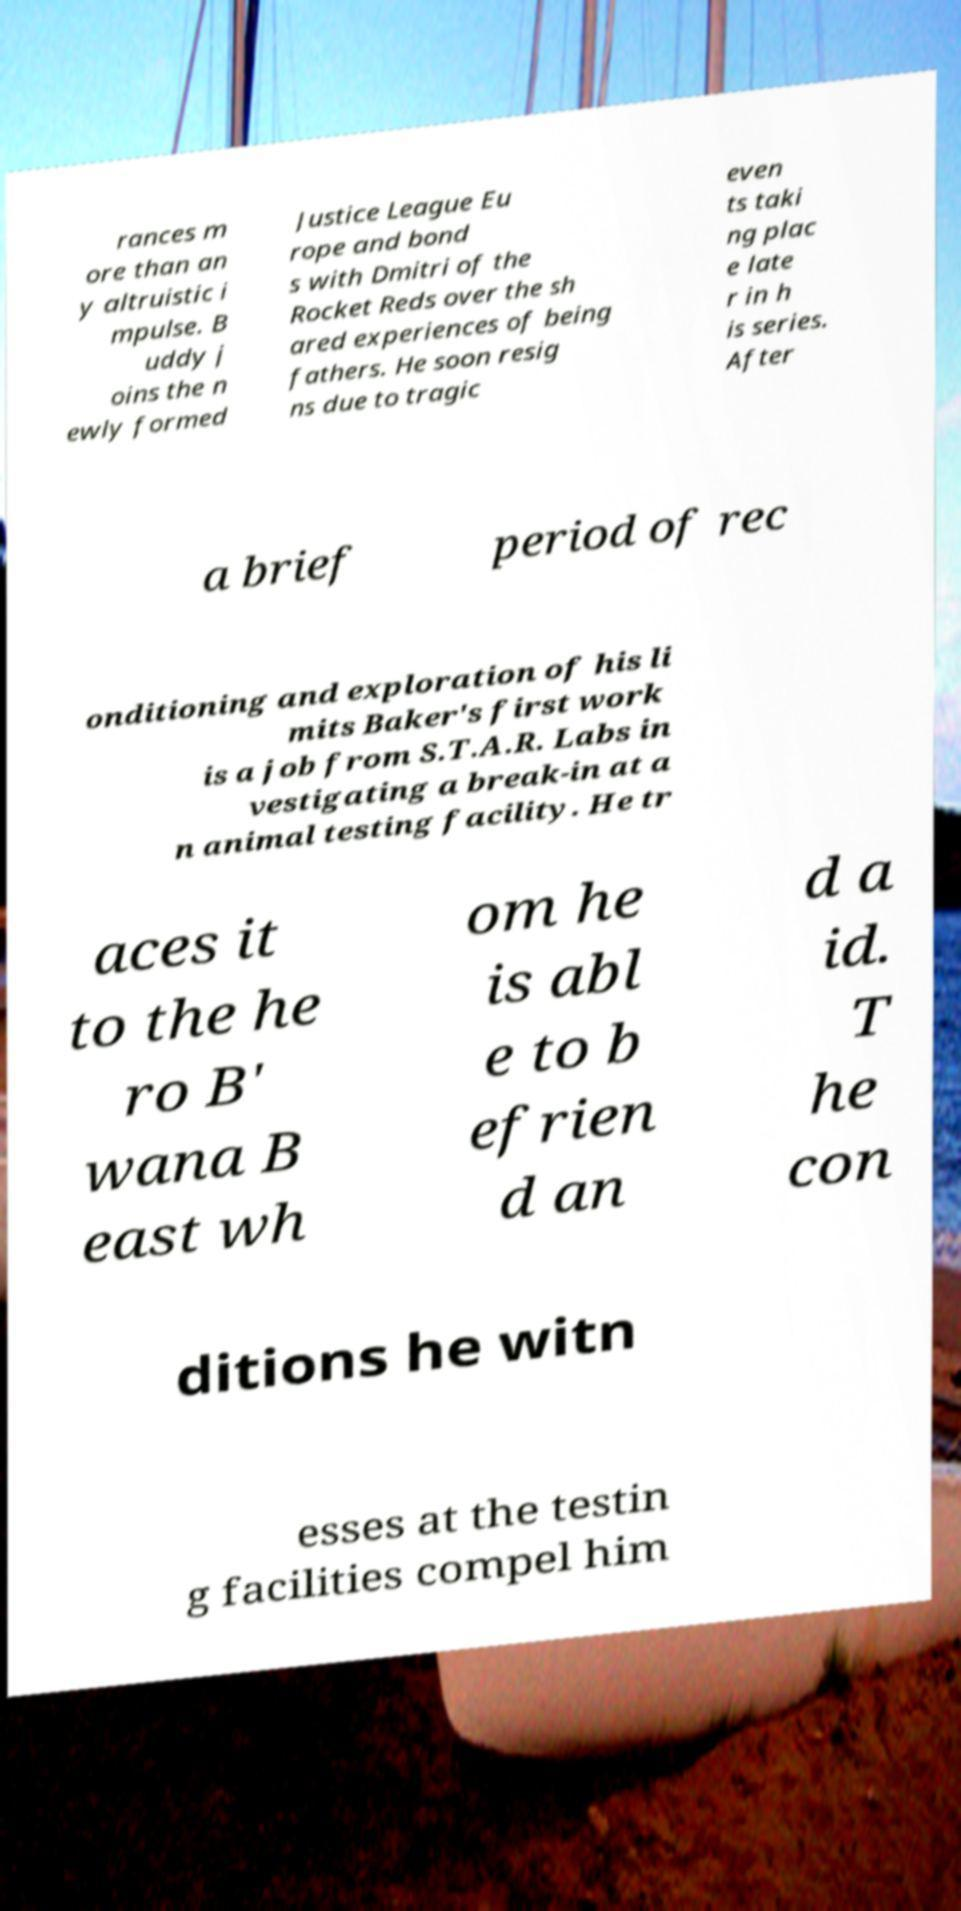There's text embedded in this image that I need extracted. Can you transcribe it verbatim? rances m ore than an y altruistic i mpulse. B uddy j oins the n ewly formed Justice League Eu rope and bond s with Dmitri of the Rocket Reds over the sh ared experiences of being fathers. He soon resig ns due to tragic even ts taki ng plac e late r in h is series. After a brief period of rec onditioning and exploration of his li mits Baker's first work is a job from S.T.A.R. Labs in vestigating a break-in at a n animal testing facility. He tr aces it to the he ro B' wana B east wh om he is abl e to b efrien d an d a id. T he con ditions he witn esses at the testin g facilities compel him 